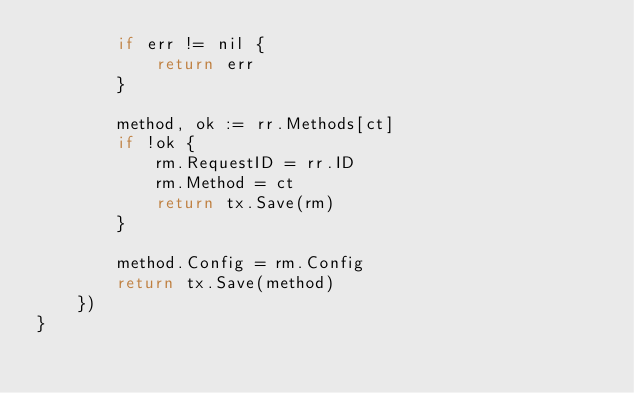<code> <loc_0><loc_0><loc_500><loc_500><_Go_>		if err != nil {
			return err
		}

		method, ok := rr.Methods[ct]
		if !ok {
			rm.RequestID = rr.ID
			rm.Method = ct
			return tx.Save(rm)
		}

		method.Config = rm.Config
		return tx.Save(method)
	})
}
</code> 